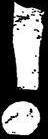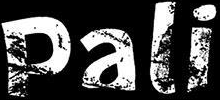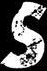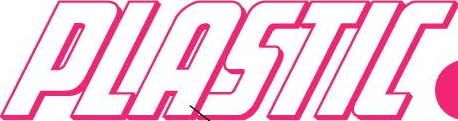What words can you see in these images in sequence, separated by a semicolon? !; Pali; s; PLASTIC 